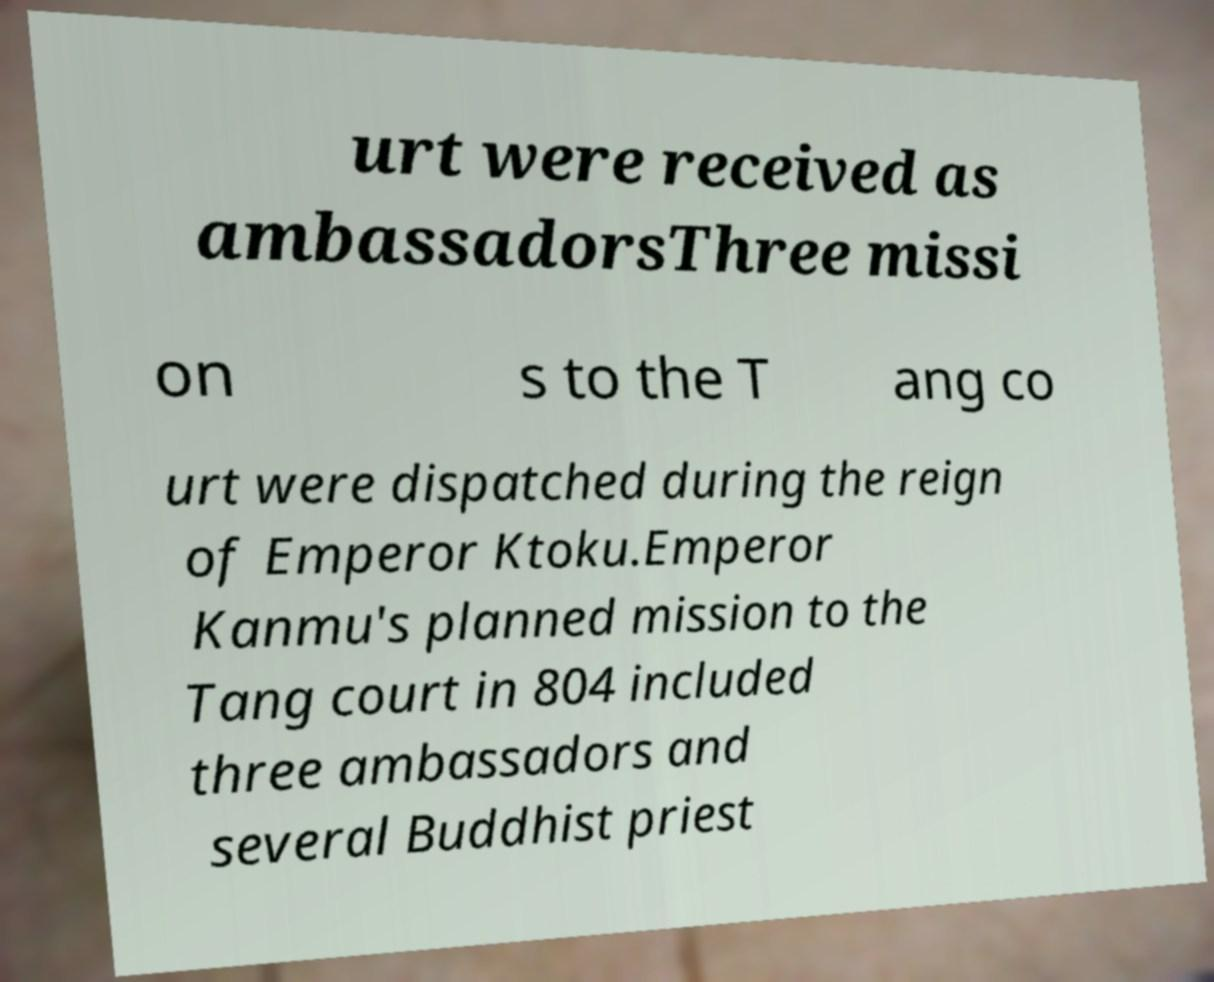Please identify and transcribe the text found in this image. urt were received as ambassadorsThree missi on s to the T ang co urt were dispatched during the reign of Emperor Ktoku.Emperor Kanmu's planned mission to the Tang court in 804 included three ambassadors and several Buddhist priest 